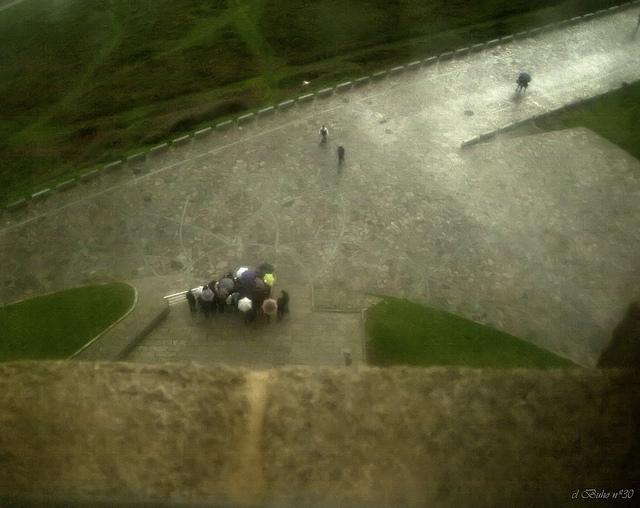How many elephants are holding their trunks up in the picture?
Give a very brief answer. 0. 